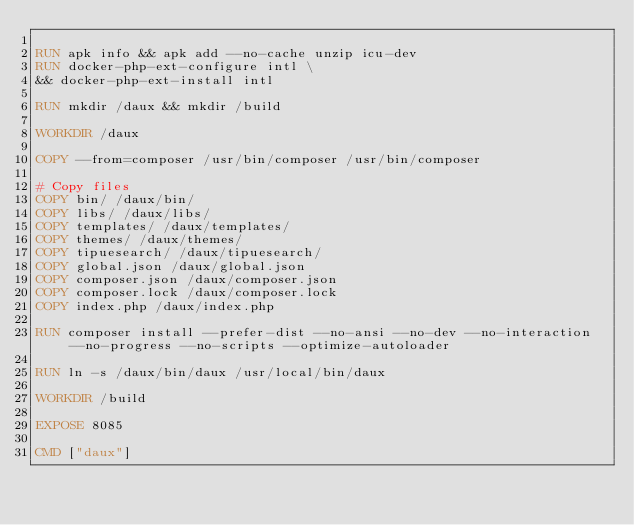Convert code to text. <code><loc_0><loc_0><loc_500><loc_500><_Dockerfile_>
RUN apk info && apk add --no-cache unzip icu-dev
RUN docker-php-ext-configure intl \
&& docker-php-ext-install intl

RUN mkdir /daux && mkdir /build

WORKDIR /daux

COPY --from=composer /usr/bin/composer /usr/bin/composer

# Copy files
COPY bin/ /daux/bin/
COPY libs/ /daux/libs/
COPY templates/ /daux/templates/
COPY themes/ /daux/themes/
COPY tipuesearch/ /daux/tipuesearch/
COPY global.json /daux/global.json
COPY composer.json /daux/composer.json
COPY composer.lock /daux/composer.lock
COPY index.php /daux/index.php

RUN composer install --prefer-dist --no-ansi --no-dev --no-interaction --no-progress --no-scripts --optimize-autoloader

RUN ln -s /daux/bin/daux /usr/local/bin/daux

WORKDIR /build

EXPOSE 8085

CMD ["daux"]
</code> 